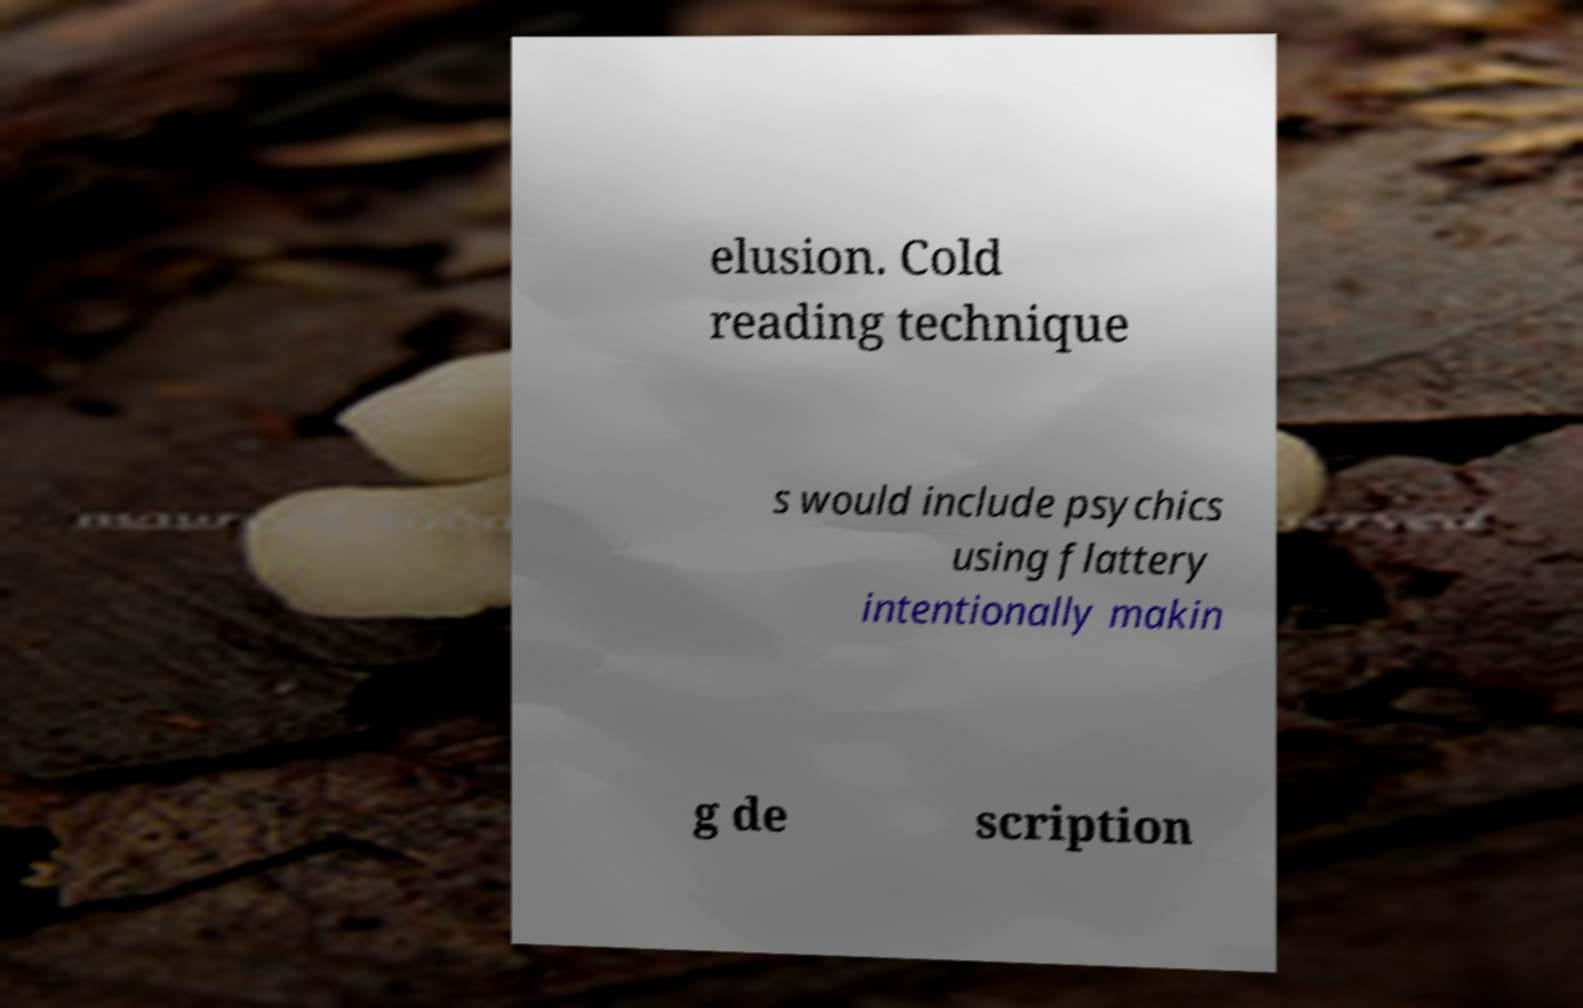Could you assist in decoding the text presented in this image and type it out clearly? elusion. Cold reading technique s would include psychics using flattery intentionally makin g de scription 